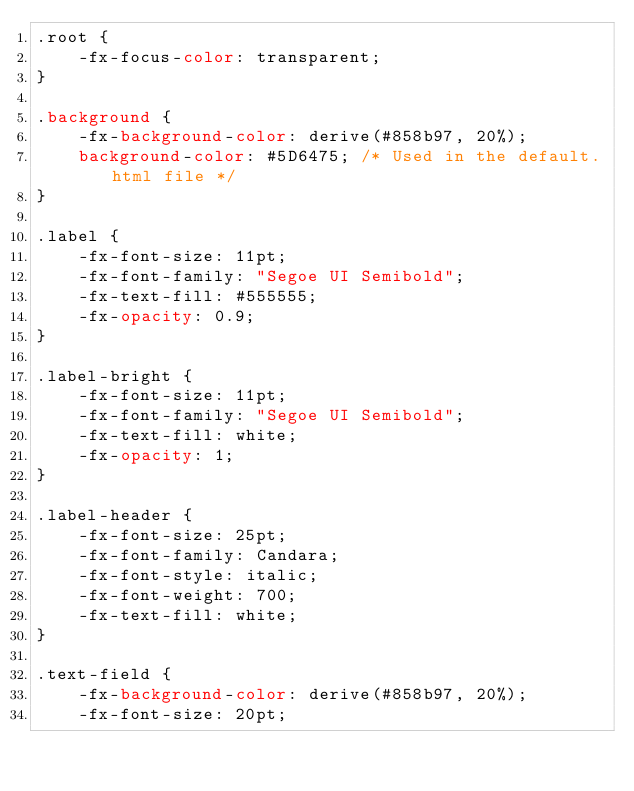Convert code to text. <code><loc_0><loc_0><loc_500><loc_500><_CSS_>.root {
    -fx-focus-color: transparent;
}

.background {
    -fx-background-color: derive(#858b97, 20%);
    background-color: #5D6475; /* Used in the default.html file */
}

.label {
    -fx-font-size: 11pt;
    -fx-font-family: "Segoe UI Semibold";
    -fx-text-fill: #555555;
    -fx-opacity: 0.9;
}

.label-bright {
    -fx-font-size: 11pt;
    -fx-font-family: "Segoe UI Semibold";
    -fx-text-fill: white;
    -fx-opacity: 1;
}

.label-header {
    -fx-font-size: 25pt;
    -fx-font-family: Candara;
    -fx-font-style: italic;
    -fx-font-weight: 700;
    -fx-text-fill: white;
}

.text-field {
    -fx-background-color: derive(#858b97, 20%);
    -fx-font-size: 20pt;</code> 